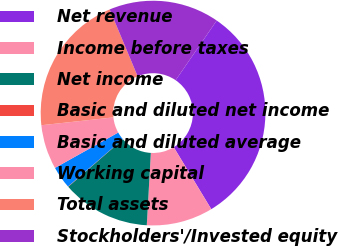Convert chart. <chart><loc_0><loc_0><loc_500><loc_500><pie_chart><fcel>Net revenue<fcel>Income before taxes<fcel>Net income<fcel>Basic and diluted net income<fcel>Basic and diluted average<fcel>Working capital<fcel>Total assets<fcel>Stockholders'/Invested equity<nl><fcel>31.74%<fcel>9.56%<fcel>12.73%<fcel>0.05%<fcel>3.22%<fcel>6.39%<fcel>20.42%<fcel>15.9%<nl></chart> 